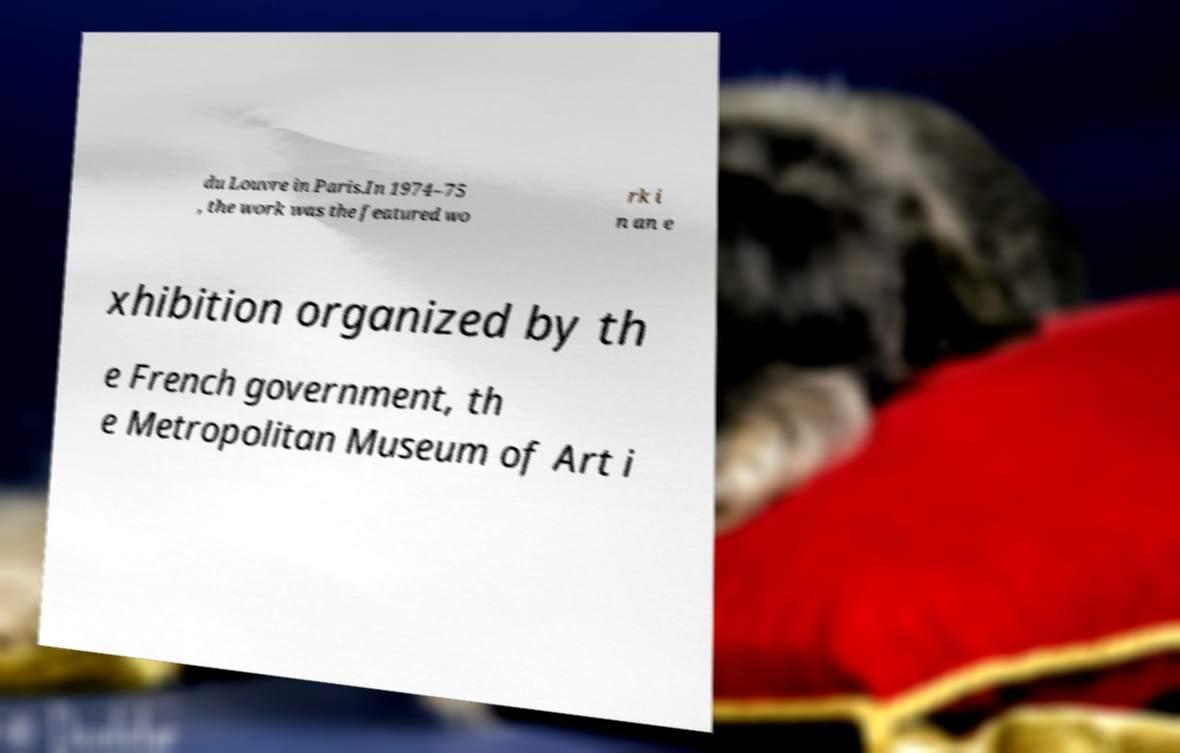For documentation purposes, I need the text within this image transcribed. Could you provide that? du Louvre in Paris.In 1974–75 , the work was the featured wo rk i n an e xhibition organized by th e French government, th e Metropolitan Museum of Art i 